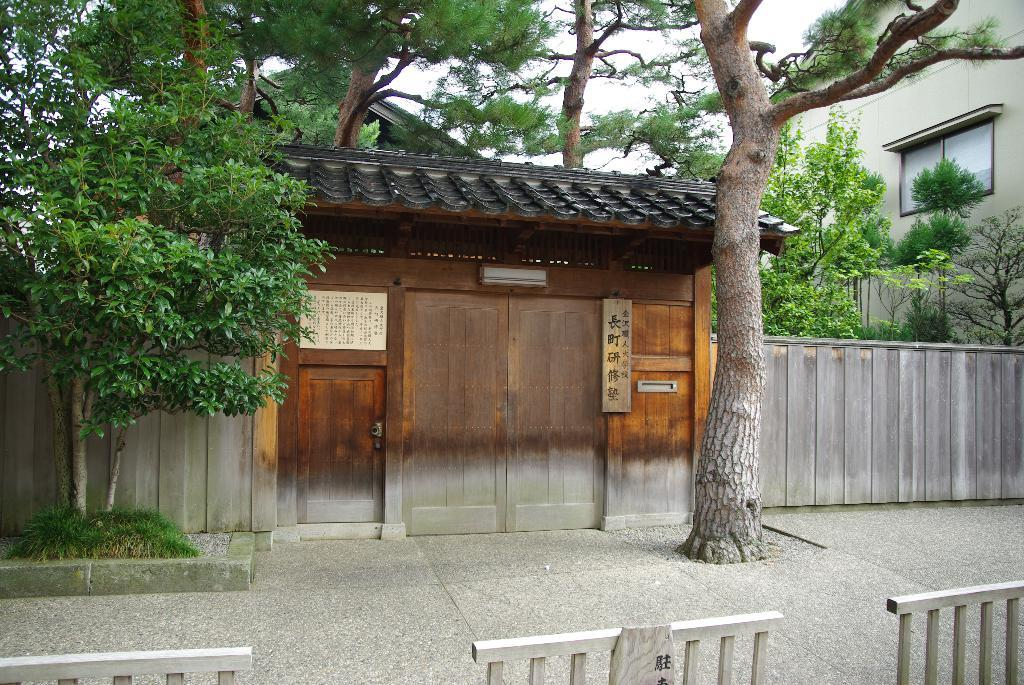What type of structures are present in the image? There are barrier gates, a wooden house, and another building on the right side of the image. What type of natural elements can be seen in the image? There are trees in the image. What type of enclosure is present in the image? There is a fence in the image. What is visible in the background of the image? The sky is visible in the background of the image. What type of steam is coming out of the wooden house in the image? There is no steam coming out of the wooden house in the image. What type of nerve is present in the image? There is no nerve present in the image; it features barrier gates, a wooden house, trees, a fence, and another building. 